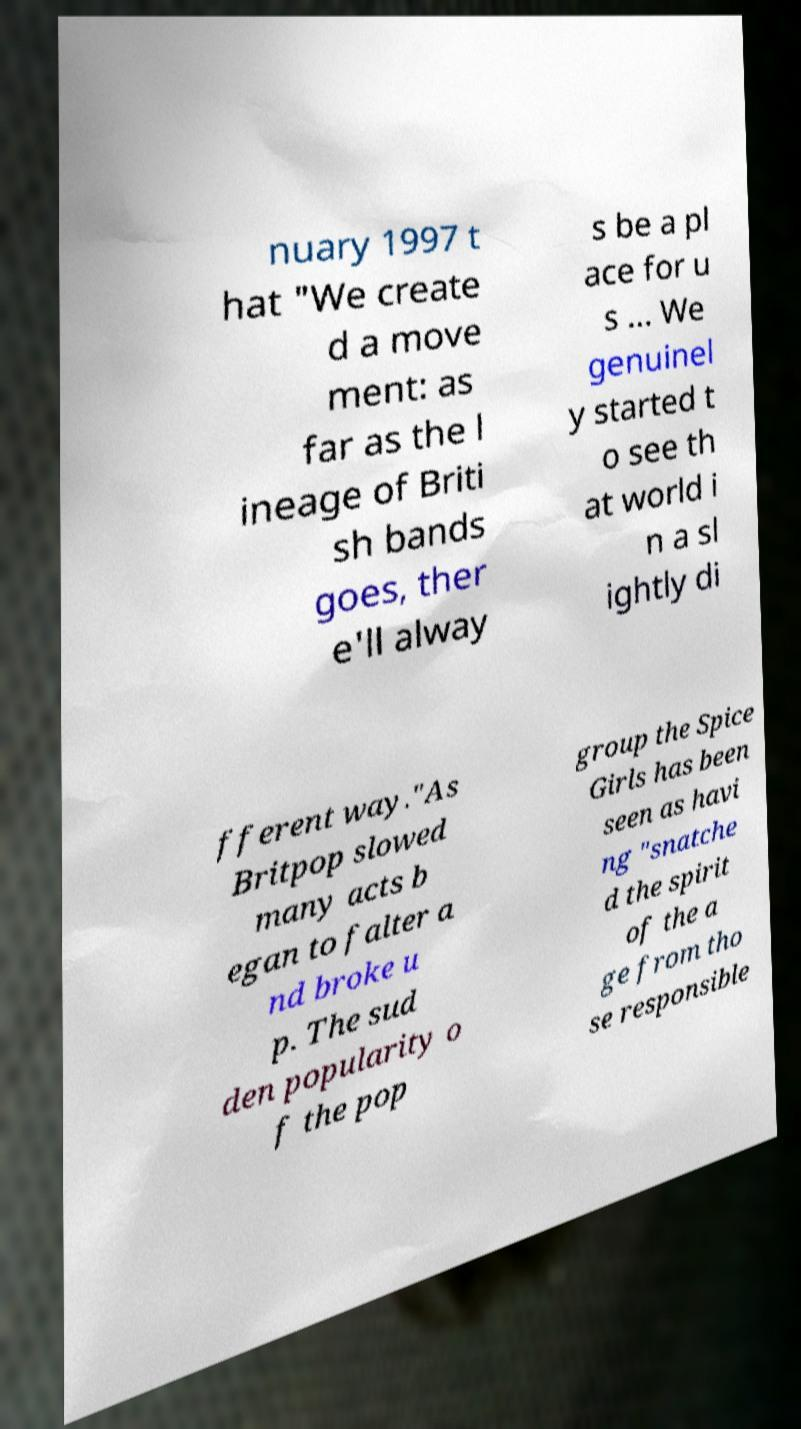For documentation purposes, I need the text within this image transcribed. Could you provide that? nuary 1997 t hat "We create d a move ment: as far as the l ineage of Briti sh bands goes, ther e'll alway s be a pl ace for u s ... We genuinel y started t o see th at world i n a sl ightly di fferent way."As Britpop slowed many acts b egan to falter a nd broke u p. The sud den popularity o f the pop group the Spice Girls has been seen as havi ng "snatche d the spirit of the a ge from tho se responsible 